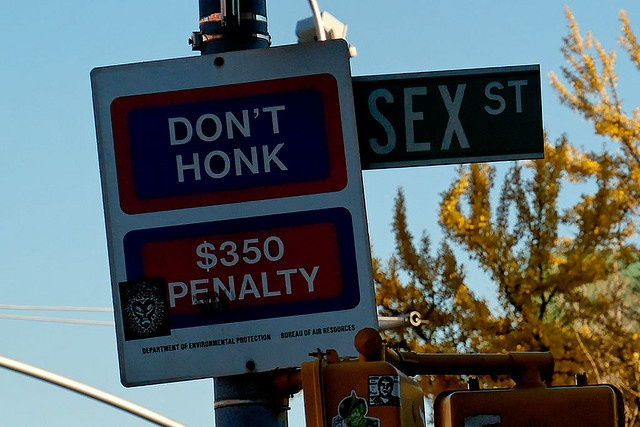Describe the objects in this image and their specific colors. I can see traffic light in lightblue, black, maroon, gray, and blue tones and traffic light in lightblue, black, maroon, and olive tones in this image. 